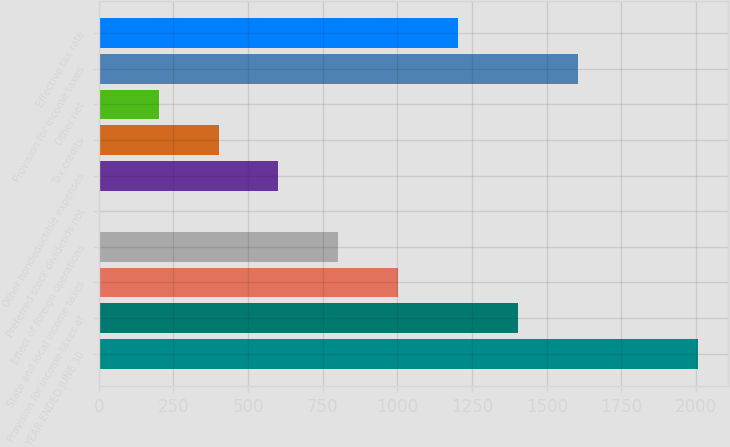Convert chart. <chart><loc_0><loc_0><loc_500><loc_500><bar_chart><fcel>YEAR ENDED JUNE 30<fcel>Provision for income taxes at<fcel>State and local income taxes<fcel>Effect of foreign operations<fcel>Preferred stock dividends not<fcel>Other nondeductible expenses<fcel>Tax credits<fcel>Other net<fcel>Provision for income taxes<fcel>Effective tax rate<nl><fcel>2006<fcel>1404.26<fcel>1003.1<fcel>802.52<fcel>0.2<fcel>601.94<fcel>401.36<fcel>200.78<fcel>1604.84<fcel>1203.68<nl></chart> 